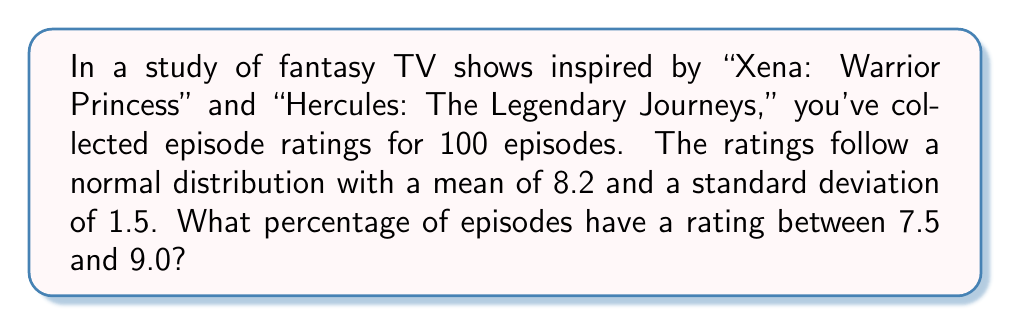Can you answer this question? To solve this problem, we need to use the properties of the normal distribution and the concept of z-scores.

Step 1: Calculate the z-scores for the given ratings.
For 7.5: $z_1 = \frac{7.5 - 8.2}{1.5} = -0.4667$
For 9.0: $z_2 = \frac{9.0 - 8.2}{1.5} = 0.5333$

Step 2: Use a standard normal distribution table or calculator to find the area under the curve between these z-scores.

Area = P(z_1 < Z < z_2) = P(Z < z_2) - P(Z < z_1)
     = P(Z < 0.5333) - P(Z < -0.4667)
     = 0.7031 - 0.3204
     = 0.3827

Step 3: Convert the area to a percentage.
Percentage = 0.3827 * 100 = 38.27%

Therefore, approximately 38.27% of the episodes have a rating between 7.5 and 9.0.
Answer: 38.27% 